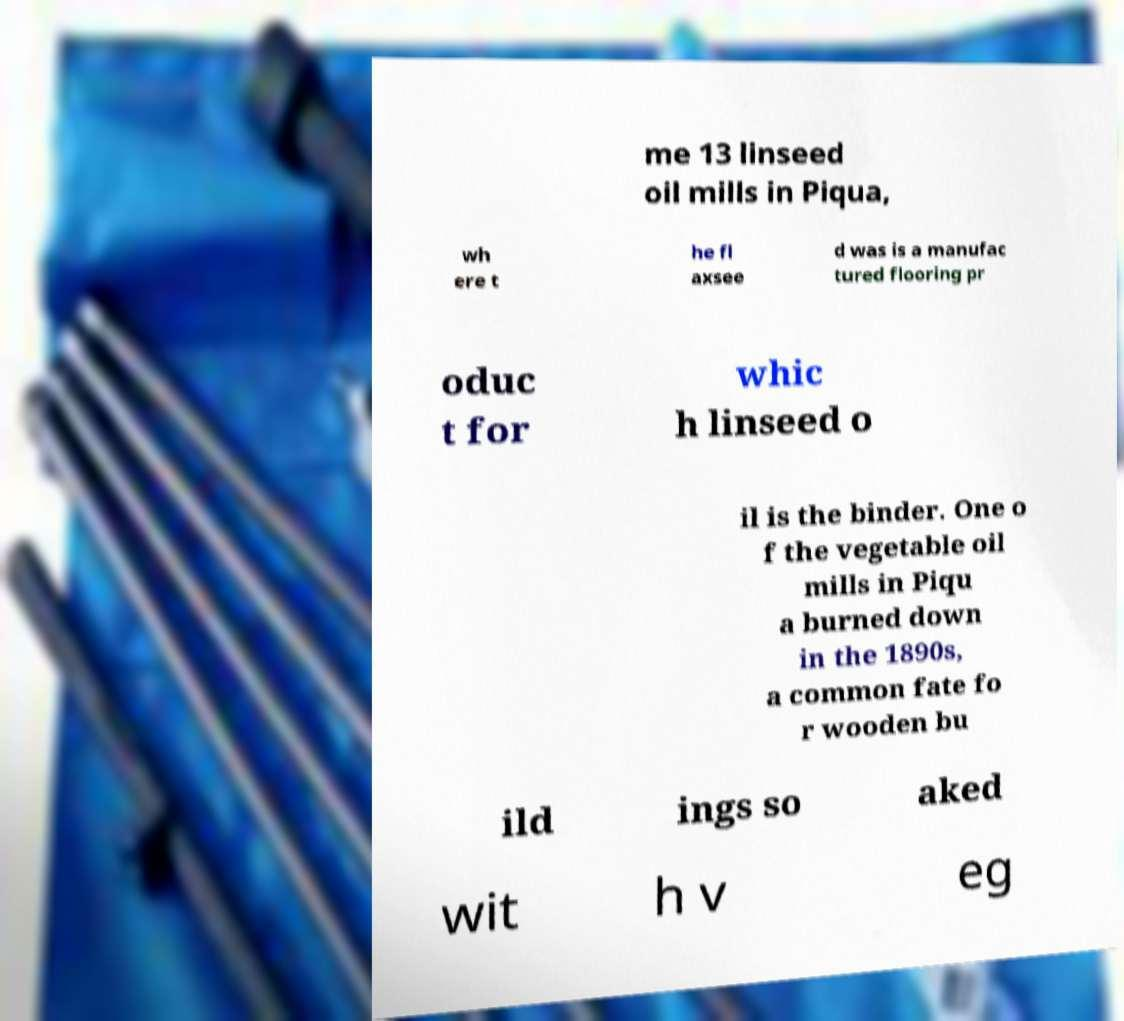There's text embedded in this image that I need extracted. Can you transcribe it verbatim? me 13 linseed oil mills in Piqua, wh ere t he fl axsee d was is a manufac tured flooring pr oduc t for whic h linseed o il is the binder. One o f the vegetable oil mills in Piqu a burned down in the 1890s, a common fate fo r wooden bu ild ings so aked wit h v eg 